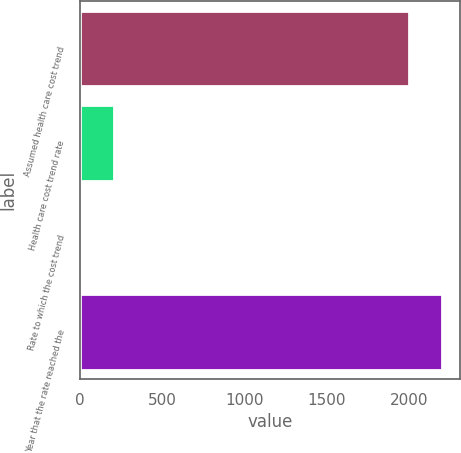<chart> <loc_0><loc_0><loc_500><loc_500><bar_chart><fcel>Assumed health care cost trend<fcel>Health care cost trend rate<fcel>Rate to which the cost trend<fcel>Year that the rate reached the<nl><fcel>2004<fcel>205.3<fcel>5<fcel>2204.3<nl></chart> 